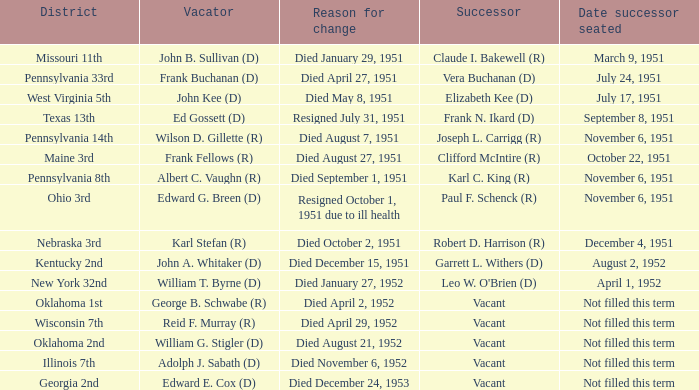Who followed in the position for kentucky's 2nd district? Garrett L. Withers (D). 